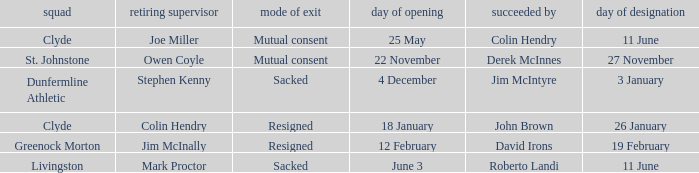Name the manner of departyre for 26 january date of appointment Resigned. 